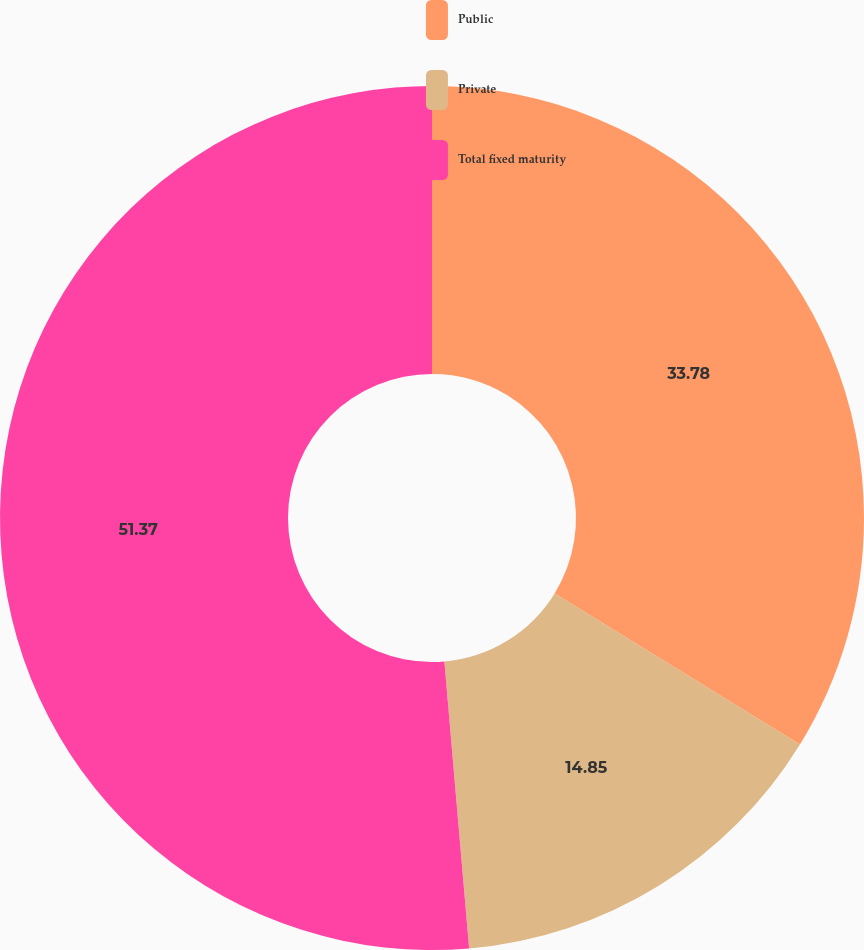Convert chart. <chart><loc_0><loc_0><loc_500><loc_500><pie_chart><fcel>Public<fcel>Private<fcel>Total fixed maturity<nl><fcel>33.78%<fcel>14.85%<fcel>51.37%<nl></chart> 